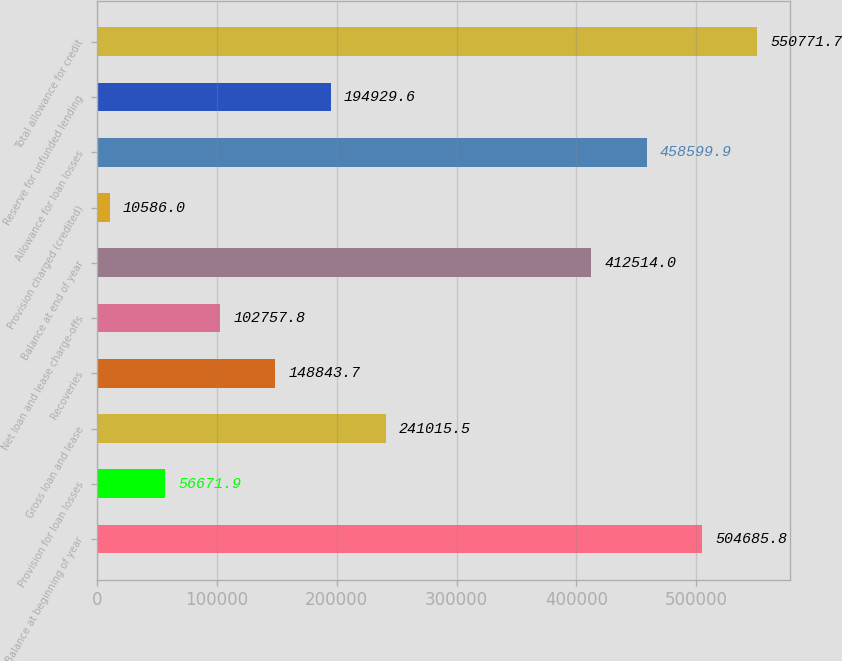<chart> <loc_0><loc_0><loc_500><loc_500><bar_chart><fcel>Balance at beginning of year<fcel>Provision for loan losses<fcel>Gross loan and lease<fcel>Recoveries<fcel>Net loan and lease charge-offs<fcel>Balance at end of year<fcel>Provision charged (credited)<fcel>Allowance for loan losses<fcel>Reserve for unfunded lending<fcel>Total allowance for credit<nl><fcel>504686<fcel>56671.9<fcel>241016<fcel>148844<fcel>102758<fcel>412514<fcel>10586<fcel>458600<fcel>194930<fcel>550772<nl></chart> 